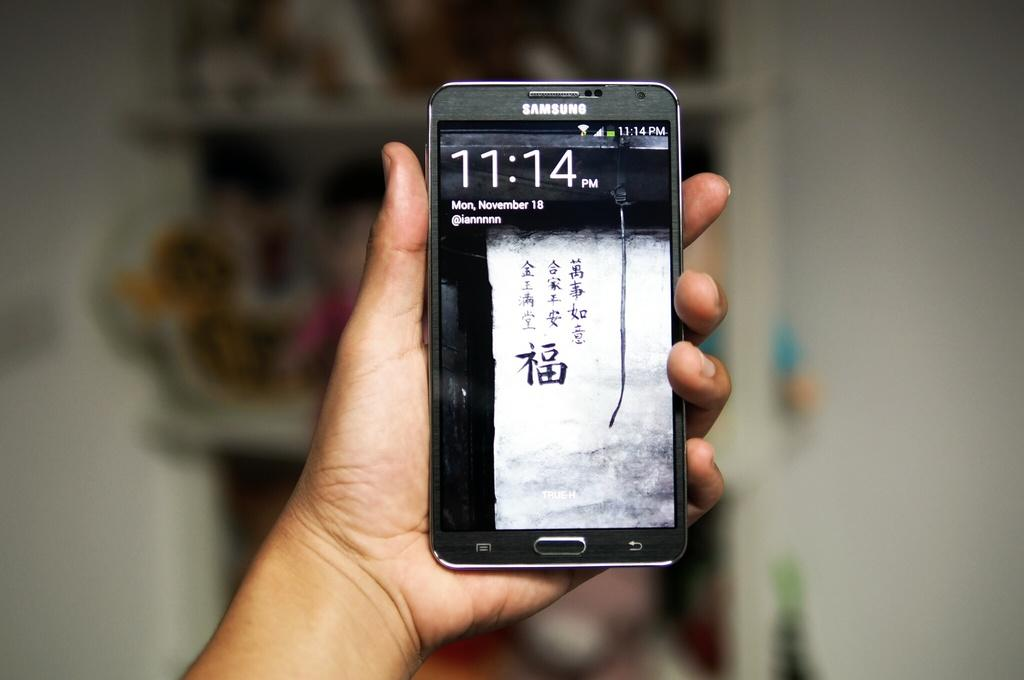Provide a one-sentence caption for the provided image. The black slim cell phone is a Samsung. 